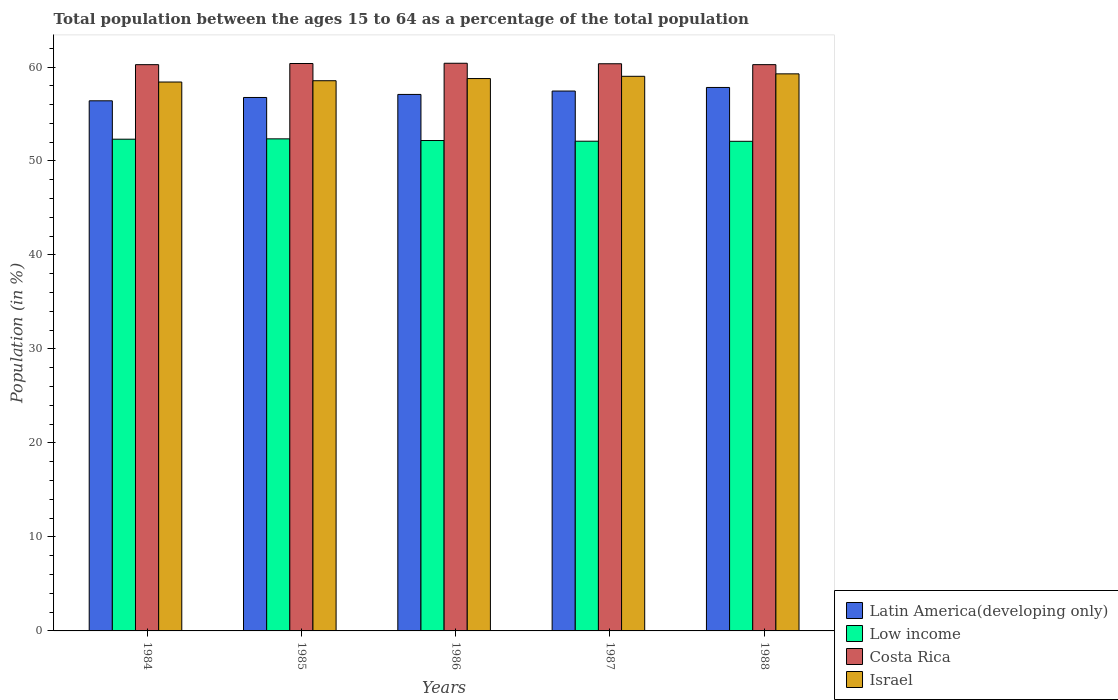Are the number of bars per tick equal to the number of legend labels?
Ensure brevity in your answer.  Yes. How many bars are there on the 5th tick from the right?
Provide a short and direct response. 4. What is the percentage of the population ages 15 to 64 in Israel in 1987?
Your answer should be compact. 59.01. Across all years, what is the maximum percentage of the population ages 15 to 64 in Latin America(developing only)?
Make the answer very short. 57.82. Across all years, what is the minimum percentage of the population ages 15 to 64 in Low income?
Keep it short and to the point. 52.1. What is the total percentage of the population ages 15 to 64 in Israel in the graph?
Provide a short and direct response. 294. What is the difference between the percentage of the population ages 15 to 64 in Latin America(developing only) in 1984 and that in 1987?
Make the answer very short. -1.04. What is the difference between the percentage of the population ages 15 to 64 in Costa Rica in 1988 and the percentage of the population ages 15 to 64 in Low income in 1987?
Keep it short and to the point. 8.15. What is the average percentage of the population ages 15 to 64 in Israel per year?
Give a very brief answer. 58.8. In the year 1987, what is the difference between the percentage of the population ages 15 to 64 in Israel and percentage of the population ages 15 to 64 in Costa Rica?
Make the answer very short. -1.34. What is the ratio of the percentage of the population ages 15 to 64 in Latin America(developing only) in 1986 to that in 1988?
Offer a very short reply. 0.99. Is the difference between the percentage of the population ages 15 to 64 in Israel in 1985 and 1987 greater than the difference between the percentage of the population ages 15 to 64 in Costa Rica in 1985 and 1987?
Ensure brevity in your answer.  No. What is the difference between the highest and the second highest percentage of the population ages 15 to 64 in Low income?
Offer a very short reply. 0.04. What is the difference between the highest and the lowest percentage of the population ages 15 to 64 in Israel?
Your answer should be compact. 0.87. In how many years, is the percentage of the population ages 15 to 64 in Israel greater than the average percentage of the population ages 15 to 64 in Israel taken over all years?
Provide a succinct answer. 2. What does the 1st bar from the left in 1987 represents?
Offer a very short reply. Latin America(developing only). What does the 2nd bar from the right in 1987 represents?
Provide a succinct answer. Costa Rica. How many bars are there?
Keep it short and to the point. 20. How many years are there in the graph?
Provide a short and direct response. 5. Are the values on the major ticks of Y-axis written in scientific E-notation?
Your response must be concise. No. Does the graph contain grids?
Provide a succinct answer. No. Where does the legend appear in the graph?
Your answer should be compact. Bottom right. How are the legend labels stacked?
Provide a short and direct response. Vertical. What is the title of the graph?
Offer a terse response. Total population between the ages 15 to 64 as a percentage of the total population. What is the Population (in %) in Latin America(developing only) in 1984?
Give a very brief answer. 56.4. What is the Population (in %) of Low income in 1984?
Make the answer very short. 52.32. What is the Population (in %) in Costa Rica in 1984?
Your response must be concise. 60.25. What is the Population (in %) in Israel in 1984?
Offer a terse response. 58.4. What is the Population (in %) of Latin America(developing only) in 1985?
Your answer should be very brief. 56.76. What is the Population (in %) of Low income in 1985?
Give a very brief answer. 52.36. What is the Population (in %) of Costa Rica in 1985?
Keep it short and to the point. 60.37. What is the Population (in %) in Israel in 1985?
Make the answer very short. 58.54. What is the Population (in %) in Latin America(developing only) in 1986?
Make the answer very short. 57.08. What is the Population (in %) of Low income in 1986?
Make the answer very short. 52.18. What is the Population (in %) of Costa Rica in 1986?
Provide a short and direct response. 60.4. What is the Population (in %) of Israel in 1986?
Your answer should be very brief. 58.77. What is the Population (in %) of Latin America(developing only) in 1987?
Offer a terse response. 57.44. What is the Population (in %) of Low income in 1987?
Provide a short and direct response. 52.11. What is the Population (in %) of Costa Rica in 1987?
Ensure brevity in your answer.  60.35. What is the Population (in %) in Israel in 1987?
Provide a short and direct response. 59.01. What is the Population (in %) in Latin America(developing only) in 1988?
Offer a very short reply. 57.82. What is the Population (in %) in Low income in 1988?
Ensure brevity in your answer.  52.1. What is the Population (in %) in Costa Rica in 1988?
Keep it short and to the point. 60.25. What is the Population (in %) of Israel in 1988?
Ensure brevity in your answer.  59.27. Across all years, what is the maximum Population (in %) in Latin America(developing only)?
Ensure brevity in your answer.  57.82. Across all years, what is the maximum Population (in %) of Low income?
Ensure brevity in your answer.  52.36. Across all years, what is the maximum Population (in %) of Costa Rica?
Offer a very short reply. 60.4. Across all years, what is the maximum Population (in %) in Israel?
Keep it short and to the point. 59.27. Across all years, what is the minimum Population (in %) in Latin America(developing only)?
Give a very brief answer. 56.4. Across all years, what is the minimum Population (in %) in Low income?
Keep it short and to the point. 52.1. Across all years, what is the minimum Population (in %) of Costa Rica?
Keep it short and to the point. 60.25. Across all years, what is the minimum Population (in %) in Israel?
Ensure brevity in your answer.  58.4. What is the total Population (in %) in Latin America(developing only) in the graph?
Your answer should be compact. 285.51. What is the total Population (in %) in Low income in the graph?
Offer a very short reply. 261.05. What is the total Population (in %) of Costa Rica in the graph?
Provide a succinct answer. 301.62. What is the total Population (in %) in Israel in the graph?
Make the answer very short. 294. What is the difference between the Population (in %) of Latin America(developing only) in 1984 and that in 1985?
Your answer should be very brief. -0.35. What is the difference between the Population (in %) of Low income in 1984 and that in 1985?
Give a very brief answer. -0.04. What is the difference between the Population (in %) of Costa Rica in 1984 and that in 1985?
Offer a terse response. -0.12. What is the difference between the Population (in %) of Israel in 1984 and that in 1985?
Provide a succinct answer. -0.14. What is the difference between the Population (in %) of Latin America(developing only) in 1984 and that in 1986?
Make the answer very short. -0.68. What is the difference between the Population (in %) of Low income in 1984 and that in 1986?
Offer a terse response. 0.14. What is the difference between the Population (in %) of Costa Rica in 1984 and that in 1986?
Provide a short and direct response. -0.15. What is the difference between the Population (in %) of Israel in 1984 and that in 1986?
Make the answer very short. -0.37. What is the difference between the Population (in %) in Latin America(developing only) in 1984 and that in 1987?
Your answer should be very brief. -1.04. What is the difference between the Population (in %) of Low income in 1984 and that in 1987?
Give a very brief answer. 0.22. What is the difference between the Population (in %) in Costa Rica in 1984 and that in 1987?
Give a very brief answer. -0.1. What is the difference between the Population (in %) in Israel in 1984 and that in 1987?
Your answer should be compact. -0.61. What is the difference between the Population (in %) in Latin America(developing only) in 1984 and that in 1988?
Ensure brevity in your answer.  -1.42. What is the difference between the Population (in %) in Low income in 1984 and that in 1988?
Ensure brevity in your answer.  0.22. What is the difference between the Population (in %) of Costa Rica in 1984 and that in 1988?
Provide a succinct answer. -0. What is the difference between the Population (in %) of Israel in 1984 and that in 1988?
Offer a very short reply. -0.87. What is the difference between the Population (in %) in Latin America(developing only) in 1985 and that in 1986?
Provide a short and direct response. -0.33. What is the difference between the Population (in %) in Low income in 1985 and that in 1986?
Provide a short and direct response. 0.18. What is the difference between the Population (in %) in Costa Rica in 1985 and that in 1986?
Make the answer very short. -0.03. What is the difference between the Population (in %) in Israel in 1985 and that in 1986?
Keep it short and to the point. -0.23. What is the difference between the Population (in %) in Latin America(developing only) in 1985 and that in 1987?
Provide a short and direct response. -0.68. What is the difference between the Population (in %) in Low income in 1985 and that in 1987?
Provide a short and direct response. 0.25. What is the difference between the Population (in %) of Costa Rica in 1985 and that in 1987?
Your answer should be very brief. 0.03. What is the difference between the Population (in %) in Israel in 1985 and that in 1987?
Provide a short and direct response. -0.47. What is the difference between the Population (in %) of Latin America(developing only) in 1985 and that in 1988?
Your answer should be compact. -1.07. What is the difference between the Population (in %) of Low income in 1985 and that in 1988?
Ensure brevity in your answer.  0.26. What is the difference between the Population (in %) in Costa Rica in 1985 and that in 1988?
Your response must be concise. 0.12. What is the difference between the Population (in %) of Israel in 1985 and that in 1988?
Offer a very short reply. -0.73. What is the difference between the Population (in %) of Latin America(developing only) in 1986 and that in 1987?
Your response must be concise. -0.36. What is the difference between the Population (in %) of Low income in 1986 and that in 1987?
Provide a succinct answer. 0.07. What is the difference between the Population (in %) of Costa Rica in 1986 and that in 1987?
Keep it short and to the point. 0.05. What is the difference between the Population (in %) of Israel in 1986 and that in 1987?
Your response must be concise. -0.24. What is the difference between the Population (in %) in Latin America(developing only) in 1986 and that in 1988?
Make the answer very short. -0.74. What is the difference between the Population (in %) of Low income in 1986 and that in 1988?
Your answer should be compact. 0.08. What is the difference between the Population (in %) of Costa Rica in 1986 and that in 1988?
Your response must be concise. 0.15. What is the difference between the Population (in %) of Israel in 1986 and that in 1988?
Make the answer very short. -0.5. What is the difference between the Population (in %) in Latin America(developing only) in 1987 and that in 1988?
Offer a very short reply. -0.38. What is the difference between the Population (in %) of Low income in 1987 and that in 1988?
Make the answer very short. 0.01. What is the difference between the Population (in %) in Costa Rica in 1987 and that in 1988?
Ensure brevity in your answer.  0.1. What is the difference between the Population (in %) in Israel in 1987 and that in 1988?
Make the answer very short. -0.26. What is the difference between the Population (in %) of Latin America(developing only) in 1984 and the Population (in %) of Low income in 1985?
Ensure brevity in your answer.  4.05. What is the difference between the Population (in %) in Latin America(developing only) in 1984 and the Population (in %) in Costa Rica in 1985?
Your answer should be compact. -3.97. What is the difference between the Population (in %) of Latin America(developing only) in 1984 and the Population (in %) of Israel in 1985?
Your answer should be compact. -2.14. What is the difference between the Population (in %) of Low income in 1984 and the Population (in %) of Costa Rica in 1985?
Make the answer very short. -8.05. What is the difference between the Population (in %) of Low income in 1984 and the Population (in %) of Israel in 1985?
Give a very brief answer. -6.22. What is the difference between the Population (in %) of Costa Rica in 1984 and the Population (in %) of Israel in 1985?
Keep it short and to the point. 1.71. What is the difference between the Population (in %) of Latin America(developing only) in 1984 and the Population (in %) of Low income in 1986?
Ensure brevity in your answer.  4.23. What is the difference between the Population (in %) of Latin America(developing only) in 1984 and the Population (in %) of Costa Rica in 1986?
Provide a short and direct response. -4. What is the difference between the Population (in %) in Latin America(developing only) in 1984 and the Population (in %) in Israel in 1986?
Make the answer very short. -2.37. What is the difference between the Population (in %) in Low income in 1984 and the Population (in %) in Costa Rica in 1986?
Keep it short and to the point. -8.08. What is the difference between the Population (in %) in Low income in 1984 and the Population (in %) in Israel in 1986?
Your answer should be very brief. -6.45. What is the difference between the Population (in %) of Costa Rica in 1984 and the Population (in %) of Israel in 1986?
Your answer should be compact. 1.48. What is the difference between the Population (in %) of Latin America(developing only) in 1984 and the Population (in %) of Low income in 1987?
Make the answer very short. 4.3. What is the difference between the Population (in %) in Latin America(developing only) in 1984 and the Population (in %) in Costa Rica in 1987?
Make the answer very short. -3.94. What is the difference between the Population (in %) in Latin America(developing only) in 1984 and the Population (in %) in Israel in 1987?
Provide a succinct answer. -2.61. What is the difference between the Population (in %) in Low income in 1984 and the Population (in %) in Costa Rica in 1987?
Keep it short and to the point. -8.03. What is the difference between the Population (in %) in Low income in 1984 and the Population (in %) in Israel in 1987?
Your answer should be compact. -6.69. What is the difference between the Population (in %) of Costa Rica in 1984 and the Population (in %) of Israel in 1987?
Your answer should be very brief. 1.24. What is the difference between the Population (in %) of Latin America(developing only) in 1984 and the Population (in %) of Low income in 1988?
Offer a very short reply. 4.31. What is the difference between the Population (in %) in Latin America(developing only) in 1984 and the Population (in %) in Costa Rica in 1988?
Offer a terse response. -3.85. What is the difference between the Population (in %) in Latin America(developing only) in 1984 and the Population (in %) in Israel in 1988?
Keep it short and to the point. -2.87. What is the difference between the Population (in %) of Low income in 1984 and the Population (in %) of Costa Rica in 1988?
Your answer should be compact. -7.93. What is the difference between the Population (in %) in Low income in 1984 and the Population (in %) in Israel in 1988?
Offer a very short reply. -6.95. What is the difference between the Population (in %) in Costa Rica in 1984 and the Population (in %) in Israel in 1988?
Your answer should be very brief. 0.98. What is the difference between the Population (in %) in Latin America(developing only) in 1985 and the Population (in %) in Low income in 1986?
Make the answer very short. 4.58. What is the difference between the Population (in %) in Latin America(developing only) in 1985 and the Population (in %) in Costa Rica in 1986?
Keep it short and to the point. -3.64. What is the difference between the Population (in %) in Latin America(developing only) in 1985 and the Population (in %) in Israel in 1986?
Offer a very short reply. -2.01. What is the difference between the Population (in %) of Low income in 1985 and the Population (in %) of Costa Rica in 1986?
Ensure brevity in your answer.  -8.04. What is the difference between the Population (in %) in Low income in 1985 and the Population (in %) in Israel in 1986?
Offer a terse response. -6.41. What is the difference between the Population (in %) of Costa Rica in 1985 and the Population (in %) of Israel in 1986?
Your answer should be compact. 1.6. What is the difference between the Population (in %) of Latin America(developing only) in 1985 and the Population (in %) of Low income in 1987?
Keep it short and to the point. 4.65. What is the difference between the Population (in %) in Latin America(developing only) in 1985 and the Population (in %) in Costa Rica in 1987?
Ensure brevity in your answer.  -3.59. What is the difference between the Population (in %) of Latin America(developing only) in 1985 and the Population (in %) of Israel in 1987?
Keep it short and to the point. -2.25. What is the difference between the Population (in %) in Low income in 1985 and the Population (in %) in Costa Rica in 1987?
Ensure brevity in your answer.  -7.99. What is the difference between the Population (in %) in Low income in 1985 and the Population (in %) in Israel in 1987?
Offer a very short reply. -6.65. What is the difference between the Population (in %) of Costa Rica in 1985 and the Population (in %) of Israel in 1987?
Your answer should be compact. 1.36. What is the difference between the Population (in %) of Latin America(developing only) in 1985 and the Population (in %) of Low income in 1988?
Keep it short and to the point. 4.66. What is the difference between the Population (in %) of Latin America(developing only) in 1985 and the Population (in %) of Costa Rica in 1988?
Keep it short and to the point. -3.49. What is the difference between the Population (in %) in Latin America(developing only) in 1985 and the Population (in %) in Israel in 1988?
Provide a succinct answer. -2.51. What is the difference between the Population (in %) in Low income in 1985 and the Population (in %) in Costa Rica in 1988?
Provide a short and direct response. -7.89. What is the difference between the Population (in %) in Low income in 1985 and the Population (in %) in Israel in 1988?
Give a very brief answer. -6.92. What is the difference between the Population (in %) of Costa Rica in 1985 and the Population (in %) of Israel in 1988?
Your response must be concise. 1.1. What is the difference between the Population (in %) in Latin America(developing only) in 1986 and the Population (in %) in Low income in 1987?
Provide a short and direct response. 4.98. What is the difference between the Population (in %) in Latin America(developing only) in 1986 and the Population (in %) in Costa Rica in 1987?
Make the answer very short. -3.26. What is the difference between the Population (in %) of Latin America(developing only) in 1986 and the Population (in %) of Israel in 1987?
Offer a terse response. -1.93. What is the difference between the Population (in %) in Low income in 1986 and the Population (in %) in Costa Rica in 1987?
Your answer should be very brief. -8.17. What is the difference between the Population (in %) of Low income in 1986 and the Population (in %) of Israel in 1987?
Your answer should be compact. -6.83. What is the difference between the Population (in %) of Costa Rica in 1986 and the Population (in %) of Israel in 1987?
Provide a short and direct response. 1.39. What is the difference between the Population (in %) of Latin America(developing only) in 1986 and the Population (in %) of Low income in 1988?
Provide a succinct answer. 4.99. What is the difference between the Population (in %) in Latin America(developing only) in 1986 and the Population (in %) in Costa Rica in 1988?
Provide a short and direct response. -3.17. What is the difference between the Population (in %) of Latin America(developing only) in 1986 and the Population (in %) of Israel in 1988?
Give a very brief answer. -2.19. What is the difference between the Population (in %) in Low income in 1986 and the Population (in %) in Costa Rica in 1988?
Give a very brief answer. -8.07. What is the difference between the Population (in %) in Low income in 1986 and the Population (in %) in Israel in 1988?
Give a very brief answer. -7.09. What is the difference between the Population (in %) in Costa Rica in 1986 and the Population (in %) in Israel in 1988?
Ensure brevity in your answer.  1.13. What is the difference between the Population (in %) in Latin America(developing only) in 1987 and the Population (in %) in Low income in 1988?
Offer a very short reply. 5.35. What is the difference between the Population (in %) in Latin America(developing only) in 1987 and the Population (in %) in Costa Rica in 1988?
Make the answer very short. -2.81. What is the difference between the Population (in %) of Latin America(developing only) in 1987 and the Population (in %) of Israel in 1988?
Keep it short and to the point. -1.83. What is the difference between the Population (in %) in Low income in 1987 and the Population (in %) in Costa Rica in 1988?
Ensure brevity in your answer.  -8.15. What is the difference between the Population (in %) of Low income in 1987 and the Population (in %) of Israel in 1988?
Provide a short and direct response. -7.17. What is the difference between the Population (in %) in Costa Rica in 1987 and the Population (in %) in Israel in 1988?
Ensure brevity in your answer.  1.07. What is the average Population (in %) in Latin America(developing only) per year?
Your answer should be compact. 57.1. What is the average Population (in %) in Low income per year?
Your answer should be very brief. 52.21. What is the average Population (in %) in Costa Rica per year?
Provide a short and direct response. 60.32. What is the average Population (in %) of Israel per year?
Your answer should be very brief. 58.8. In the year 1984, what is the difference between the Population (in %) in Latin America(developing only) and Population (in %) in Low income?
Offer a terse response. 4.08. In the year 1984, what is the difference between the Population (in %) of Latin America(developing only) and Population (in %) of Costa Rica?
Provide a short and direct response. -3.85. In the year 1984, what is the difference between the Population (in %) in Latin America(developing only) and Population (in %) in Israel?
Ensure brevity in your answer.  -2. In the year 1984, what is the difference between the Population (in %) of Low income and Population (in %) of Costa Rica?
Your answer should be very brief. -7.93. In the year 1984, what is the difference between the Population (in %) in Low income and Population (in %) in Israel?
Keep it short and to the point. -6.08. In the year 1984, what is the difference between the Population (in %) of Costa Rica and Population (in %) of Israel?
Your answer should be very brief. 1.85. In the year 1985, what is the difference between the Population (in %) in Latin America(developing only) and Population (in %) in Low income?
Your answer should be very brief. 4.4. In the year 1985, what is the difference between the Population (in %) in Latin America(developing only) and Population (in %) in Costa Rica?
Your response must be concise. -3.61. In the year 1985, what is the difference between the Population (in %) in Latin America(developing only) and Population (in %) in Israel?
Offer a terse response. -1.78. In the year 1985, what is the difference between the Population (in %) in Low income and Population (in %) in Costa Rica?
Offer a very short reply. -8.02. In the year 1985, what is the difference between the Population (in %) in Low income and Population (in %) in Israel?
Your response must be concise. -6.19. In the year 1985, what is the difference between the Population (in %) of Costa Rica and Population (in %) of Israel?
Give a very brief answer. 1.83. In the year 1986, what is the difference between the Population (in %) of Latin America(developing only) and Population (in %) of Low income?
Offer a terse response. 4.9. In the year 1986, what is the difference between the Population (in %) of Latin America(developing only) and Population (in %) of Costa Rica?
Your response must be concise. -3.32. In the year 1986, what is the difference between the Population (in %) in Latin America(developing only) and Population (in %) in Israel?
Provide a succinct answer. -1.69. In the year 1986, what is the difference between the Population (in %) in Low income and Population (in %) in Costa Rica?
Provide a short and direct response. -8.22. In the year 1986, what is the difference between the Population (in %) of Low income and Population (in %) of Israel?
Offer a terse response. -6.59. In the year 1986, what is the difference between the Population (in %) in Costa Rica and Population (in %) in Israel?
Your response must be concise. 1.63. In the year 1987, what is the difference between the Population (in %) of Latin America(developing only) and Population (in %) of Low income?
Your answer should be compact. 5.34. In the year 1987, what is the difference between the Population (in %) in Latin America(developing only) and Population (in %) in Costa Rica?
Offer a very short reply. -2.9. In the year 1987, what is the difference between the Population (in %) of Latin America(developing only) and Population (in %) of Israel?
Offer a terse response. -1.57. In the year 1987, what is the difference between the Population (in %) of Low income and Population (in %) of Costa Rica?
Give a very brief answer. -8.24. In the year 1987, what is the difference between the Population (in %) of Low income and Population (in %) of Israel?
Offer a very short reply. -6.91. In the year 1987, what is the difference between the Population (in %) of Costa Rica and Population (in %) of Israel?
Provide a succinct answer. 1.33. In the year 1988, what is the difference between the Population (in %) of Latin America(developing only) and Population (in %) of Low income?
Provide a short and direct response. 5.73. In the year 1988, what is the difference between the Population (in %) in Latin America(developing only) and Population (in %) in Costa Rica?
Offer a very short reply. -2.43. In the year 1988, what is the difference between the Population (in %) in Latin America(developing only) and Population (in %) in Israel?
Keep it short and to the point. -1.45. In the year 1988, what is the difference between the Population (in %) in Low income and Population (in %) in Costa Rica?
Ensure brevity in your answer.  -8.16. In the year 1988, what is the difference between the Population (in %) in Low income and Population (in %) in Israel?
Offer a terse response. -7.18. In the year 1988, what is the difference between the Population (in %) of Costa Rica and Population (in %) of Israel?
Your answer should be very brief. 0.98. What is the ratio of the Population (in %) in Latin America(developing only) in 1984 to that in 1985?
Offer a terse response. 0.99. What is the ratio of the Population (in %) in Low income in 1984 to that in 1985?
Ensure brevity in your answer.  1. What is the ratio of the Population (in %) in Costa Rica in 1984 to that in 1985?
Provide a succinct answer. 1. What is the ratio of the Population (in %) of Israel in 1984 to that in 1985?
Your answer should be compact. 1. What is the ratio of the Population (in %) in Latin America(developing only) in 1984 to that in 1986?
Ensure brevity in your answer.  0.99. What is the ratio of the Population (in %) of Low income in 1984 to that in 1986?
Provide a short and direct response. 1. What is the ratio of the Population (in %) of Costa Rica in 1984 to that in 1986?
Your answer should be compact. 1. What is the ratio of the Population (in %) in Israel in 1984 to that in 1986?
Make the answer very short. 0.99. What is the ratio of the Population (in %) of Latin America(developing only) in 1984 to that in 1987?
Ensure brevity in your answer.  0.98. What is the ratio of the Population (in %) of Latin America(developing only) in 1984 to that in 1988?
Your response must be concise. 0.98. What is the ratio of the Population (in %) in Low income in 1984 to that in 1988?
Make the answer very short. 1. What is the ratio of the Population (in %) in Costa Rica in 1984 to that in 1988?
Make the answer very short. 1. What is the ratio of the Population (in %) of Israel in 1984 to that in 1988?
Offer a terse response. 0.99. What is the ratio of the Population (in %) in Latin America(developing only) in 1985 to that in 1986?
Offer a very short reply. 0.99. What is the ratio of the Population (in %) of Low income in 1985 to that in 1986?
Keep it short and to the point. 1. What is the ratio of the Population (in %) of Costa Rica in 1985 to that in 1986?
Keep it short and to the point. 1. What is the ratio of the Population (in %) of Israel in 1985 to that in 1986?
Your response must be concise. 1. What is the ratio of the Population (in %) in Costa Rica in 1985 to that in 1987?
Give a very brief answer. 1. What is the ratio of the Population (in %) in Latin America(developing only) in 1985 to that in 1988?
Your response must be concise. 0.98. What is the ratio of the Population (in %) of Low income in 1985 to that in 1988?
Offer a terse response. 1. What is the ratio of the Population (in %) of Costa Rica in 1985 to that in 1988?
Give a very brief answer. 1. What is the ratio of the Population (in %) in Israel in 1985 to that in 1988?
Give a very brief answer. 0.99. What is the ratio of the Population (in %) in Latin America(developing only) in 1986 to that in 1987?
Offer a very short reply. 0.99. What is the ratio of the Population (in %) of Low income in 1986 to that in 1987?
Give a very brief answer. 1. What is the ratio of the Population (in %) of Israel in 1986 to that in 1987?
Offer a very short reply. 1. What is the ratio of the Population (in %) in Latin America(developing only) in 1986 to that in 1988?
Ensure brevity in your answer.  0.99. What is the ratio of the Population (in %) of Costa Rica in 1986 to that in 1988?
Give a very brief answer. 1. What is the ratio of the Population (in %) in Israel in 1986 to that in 1988?
Your answer should be compact. 0.99. What is the ratio of the Population (in %) in Low income in 1987 to that in 1988?
Make the answer very short. 1. What is the ratio of the Population (in %) in Costa Rica in 1987 to that in 1988?
Offer a very short reply. 1. What is the ratio of the Population (in %) of Israel in 1987 to that in 1988?
Your response must be concise. 1. What is the difference between the highest and the second highest Population (in %) of Latin America(developing only)?
Make the answer very short. 0.38. What is the difference between the highest and the second highest Population (in %) in Low income?
Ensure brevity in your answer.  0.04. What is the difference between the highest and the second highest Population (in %) in Costa Rica?
Offer a terse response. 0.03. What is the difference between the highest and the second highest Population (in %) of Israel?
Keep it short and to the point. 0.26. What is the difference between the highest and the lowest Population (in %) of Latin America(developing only)?
Offer a very short reply. 1.42. What is the difference between the highest and the lowest Population (in %) in Low income?
Ensure brevity in your answer.  0.26. What is the difference between the highest and the lowest Population (in %) in Costa Rica?
Your answer should be very brief. 0.15. What is the difference between the highest and the lowest Population (in %) in Israel?
Ensure brevity in your answer.  0.87. 